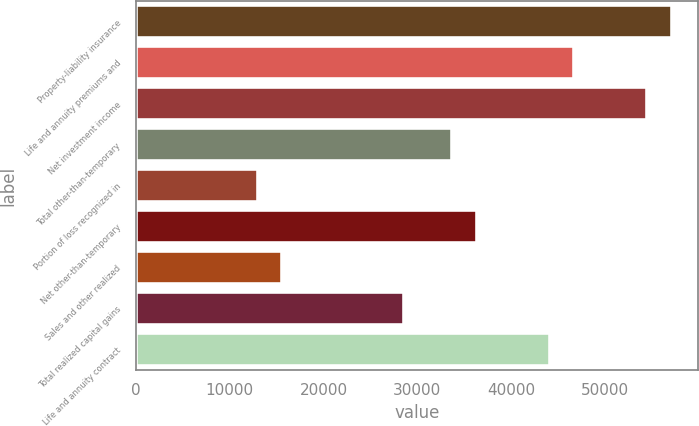<chart> <loc_0><loc_0><loc_500><loc_500><bar_chart><fcel>Property-liability insurance<fcel>Life and annuity premiums and<fcel>Net investment income<fcel>Total other-than-temporary<fcel>Portion of loss recognized in<fcel>Net other-than-temporary<fcel>Sales and other realized<fcel>Total realized capital gains<fcel>Life and annuity contract<nl><fcel>57104.4<fcel>46722<fcel>54508.8<fcel>33743.9<fcel>12978.9<fcel>36339.5<fcel>15574.5<fcel>28552.6<fcel>44126.3<nl></chart> 